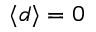Convert formula to latex. <formula><loc_0><loc_0><loc_500><loc_500>\langle d \rangle = 0</formula> 